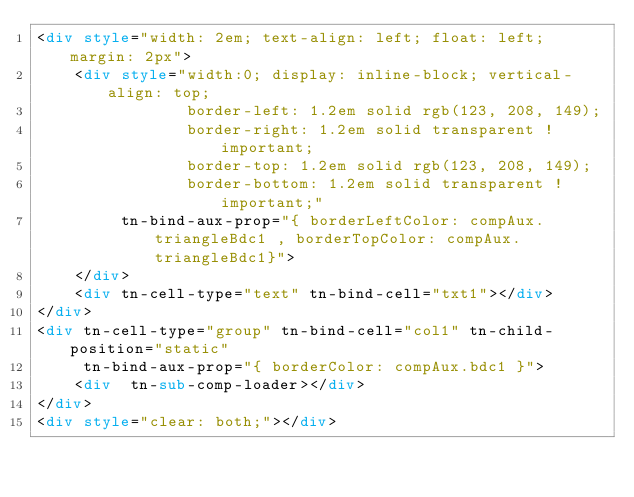<code> <loc_0><loc_0><loc_500><loc_500><_HTML_><div style="width: 2em; text-align: left; float: left; margin: 2px">
    <div style="width:0; display: inline-block; vertical-align: top;
                border-left: 1.2em solid rgb(123, 208, 149);
                border-right: 1.2em solid transparent !important;
                border-top: 1.2em solid rgb(123, 208, 149);
                border-bottom: 1.2em solid transparent !important;"
         tn-bind-aux-prop="{ borderLeftColor: compAux.triangleBdc1 , borderTopColor: compAux.triangleBdc1}">
    </div>
    <div tn-cell-type="text" tn-bind-cell="txt1"></div>
</div>
<div tn-cell-type="group" tn-bind-cell="col1" tn-child-position="static"
     tn-bind-aux-prop="{ borderColor: compAux.bdc1 }">
    <div  tn-sub-comp-loader></div>
</div>
<div style="clear: both;"></div></code> 